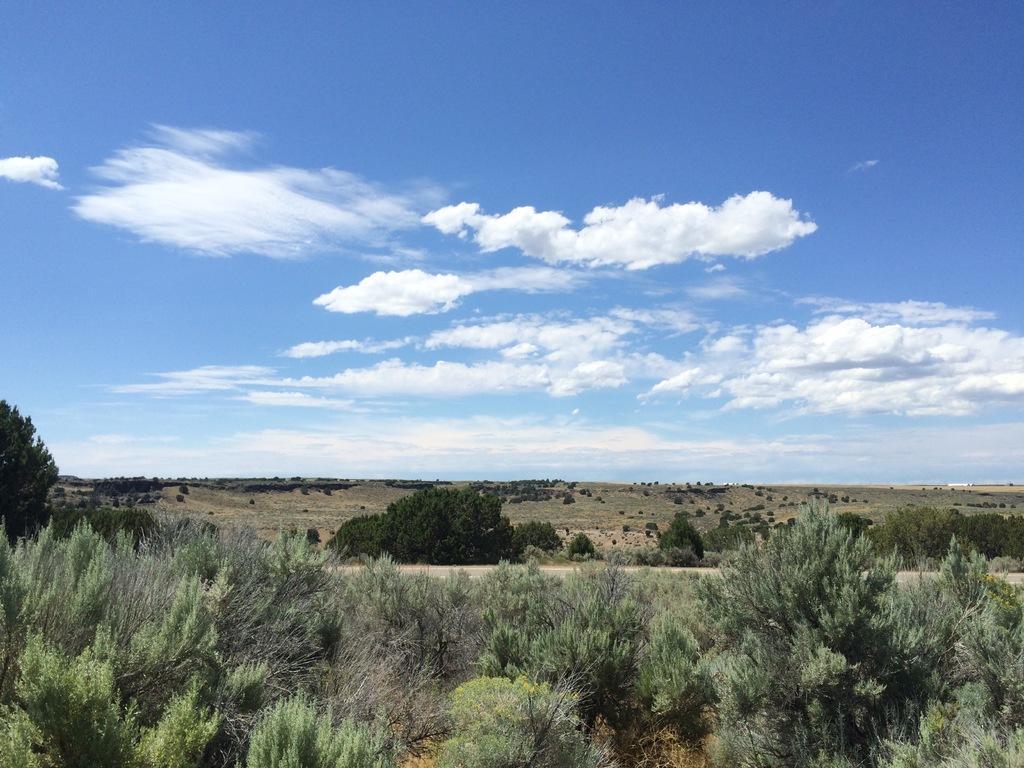Describe this image in one or two sentences. In this image I can see few trees, plants and the sky is in blue and white color. 